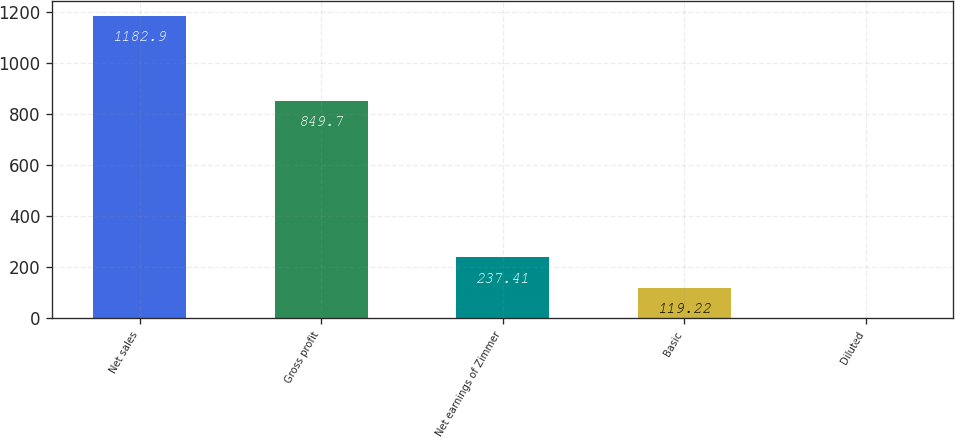Convert chart. <chart><loc_0><loc_0><loc_500><loc_500><bar_chart><fcel>Net sales<fcel>Gross profit<fcel>Net earnings of Zimmer<fcel>Basic<fcel>Diluted<nl><fcel>1182.9<fcel>849.7<fcel>237.41<fcel>119.22<fcel>1.03<nl></chart> 